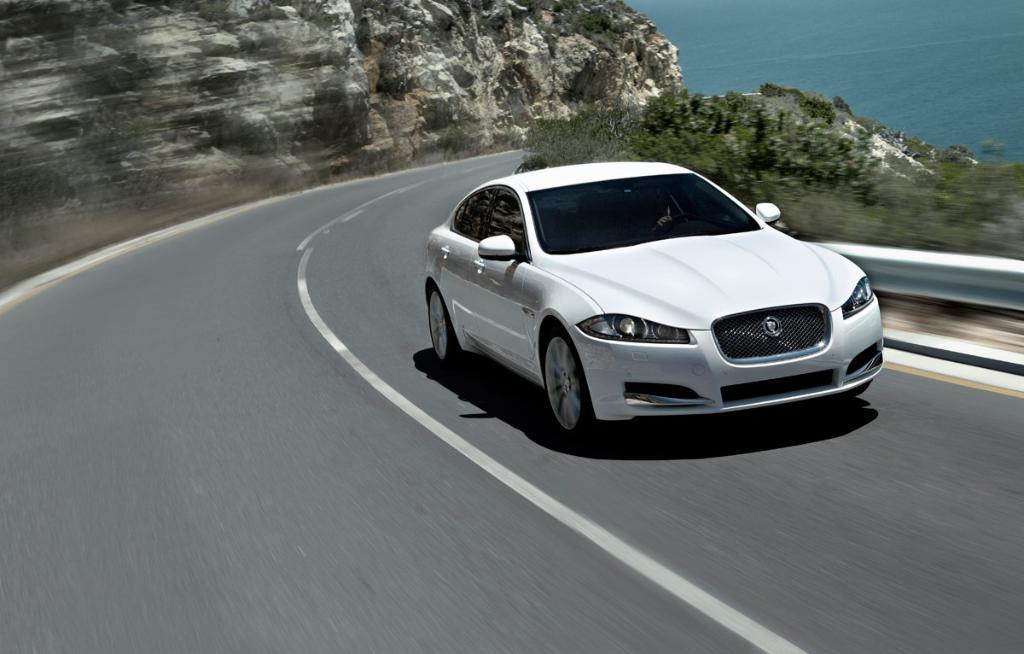What color is the car in the image? The car in the image is white. Where is the car located in the image? The car is on the road in the image. What can be seen in the background of the image? There are plants, rocks, and water visible in the background of the image. What type of verse can be heard recited by the beetle in the image? There is no beetle present in the image, and therefore no recitation of verses can be heard. 